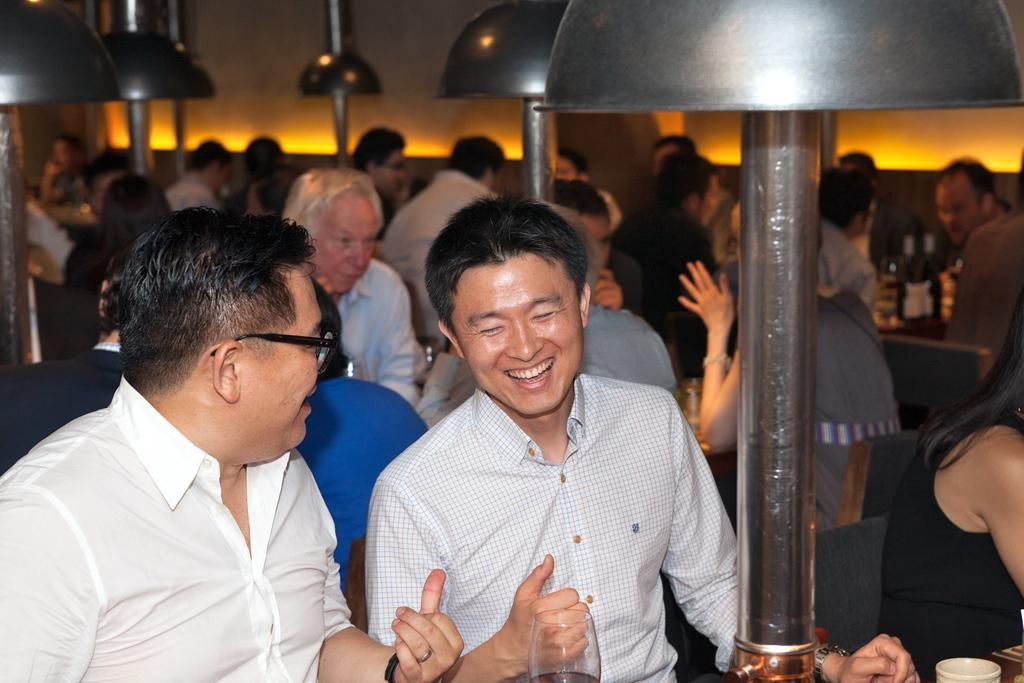What are the people in the image doing? The people in the image are sitting on chairs. What is in front of the chairs? There is a table in front of the chairs. What is on the table? There are light poles on the table. What hour is it in the image? The provided facts do not mention the time of day, so it is impossible to determine the hour in the image. 